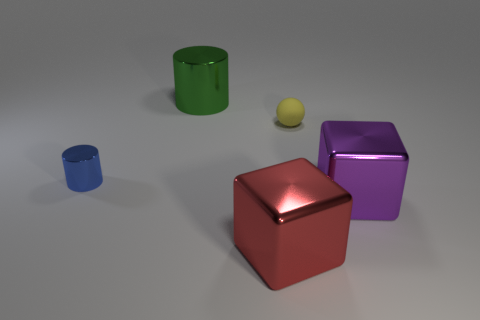What can you infer about the lighting and texture in this scene? The scene appears to be softly lit from above, given the gentle shadows under the objects and the soft illumination on their upper surfaces. Each object has a reflective quality, indicating textures that are likely metallic or polished. The red cube, in particular, has high reflectivity, suggesting a very smooth, shiny surface, whereas the yellow sphere and purple cube have moderately reflective textures. 